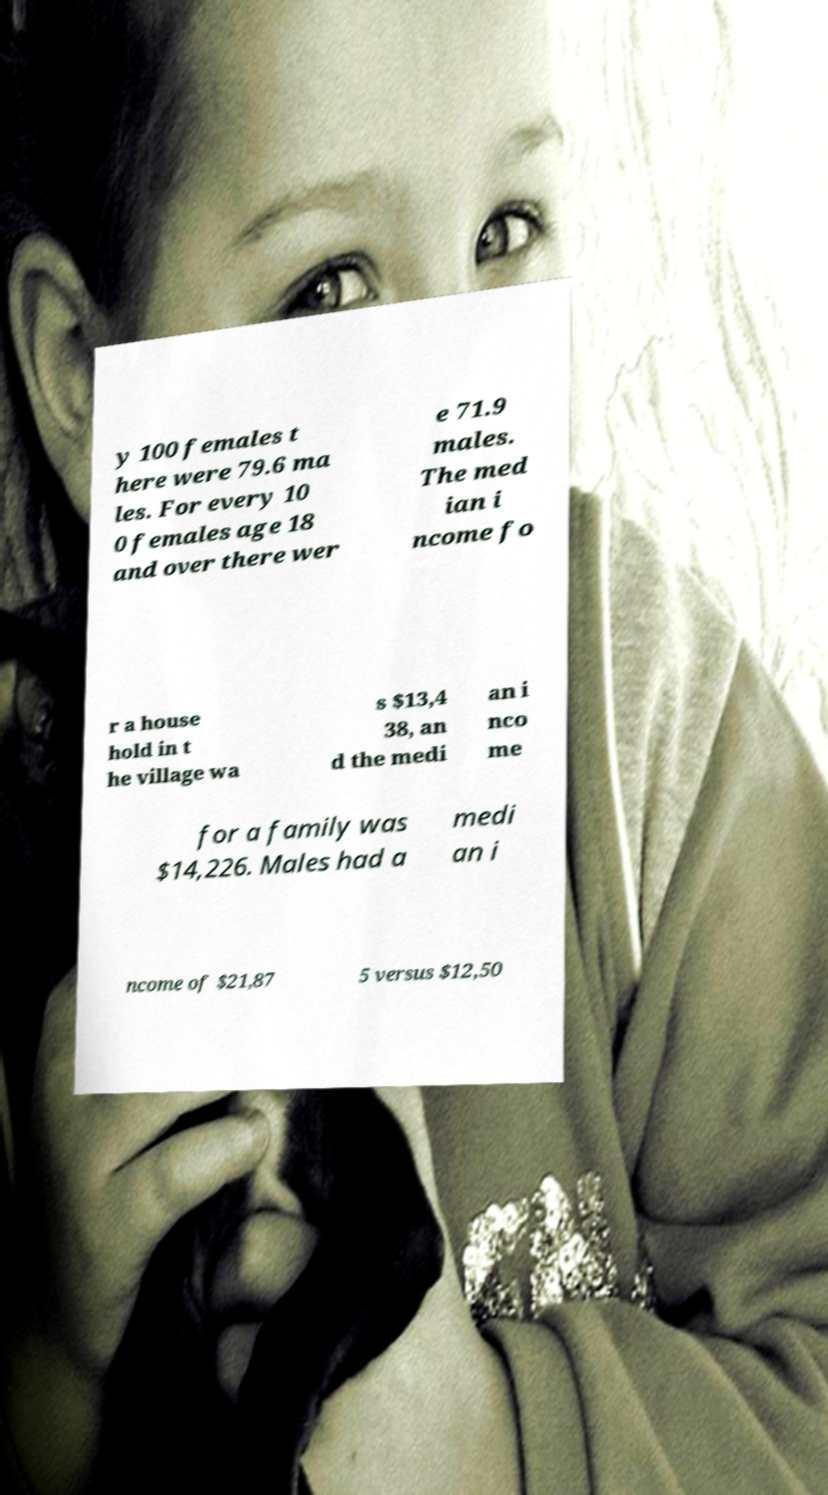There's text embedded in this image that I need extracted. Can you transcribe it verbatim? y 100 females t here were 79.6 ma les. For every 10 0 females age 18 and over there wer e 71.9 males. The med ian i ncome fo r a house hold in t he village wa s $13,4 38, an d the medi an i nco me for a family was $14,226. Males had a medi an i ncome of $21,87 5 versus $12,50 